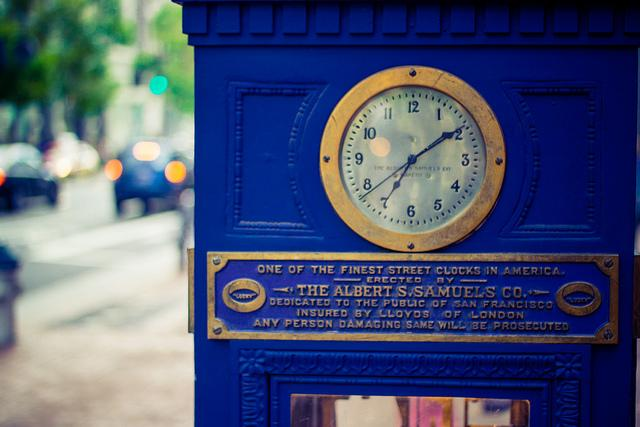In which metropolitan area is this clock installed?

Choices:
A) boston
B) san francisco
C) new york
D) london san francisco 